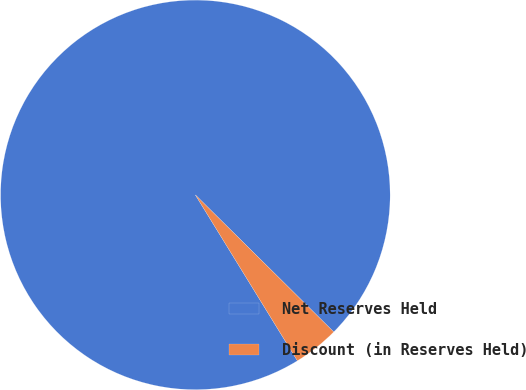<chart> <loc_0><loc_0><loc_500><loc_500><pie_chart><fcel>Net Reserves Held<fcel>Discount (in Reserves Held)<nl><fcel>96.2%<fcel>3.8%<nl></chart> 